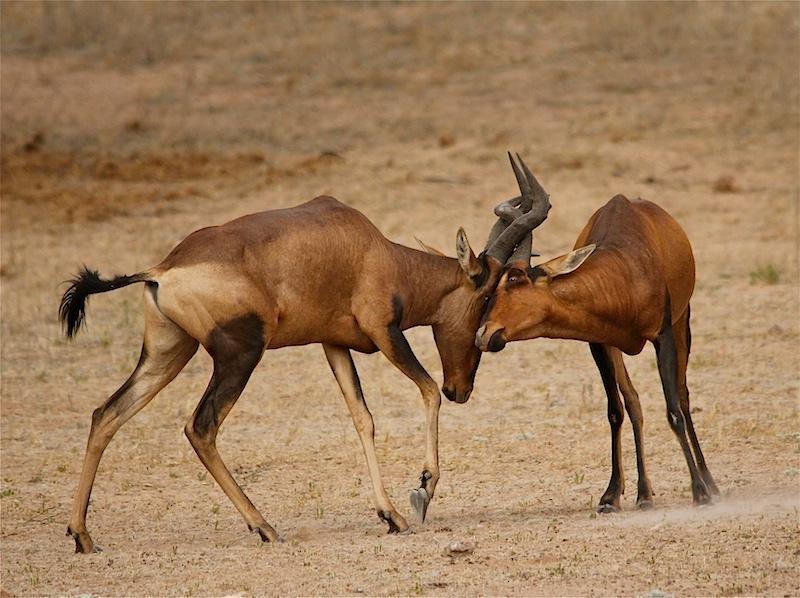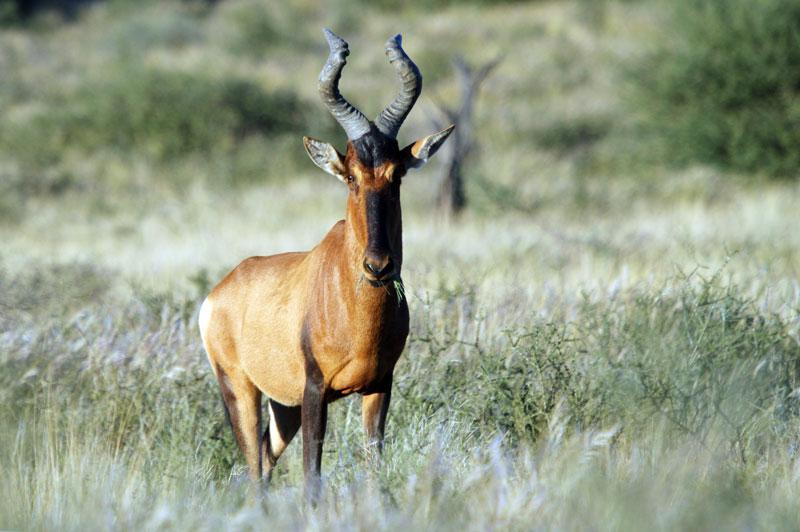The first image is the image on the left, the second image is the image on the right. Examine the images to the left and right. Is the description "There are two antelopes in the wild." accurate? Answer yes or no. No. The first image is the image on the left, the second image is the image on the right. For the images shown, is this caption "An image shows one horned animal standing and facing the camera." true? Answer yes or no. Yes. 